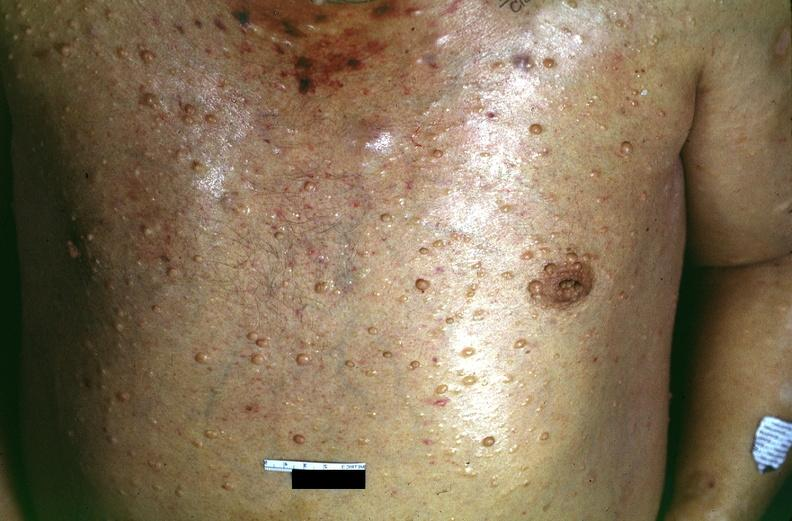where is this?
Answer the question using a single word or phrase. Skin 